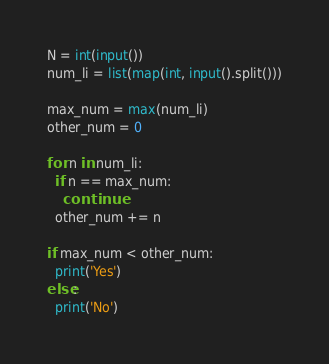Convert code to text. <code><loc_0><loc_0><loc_500><loc_500><_Python_>N = int(input())
num_li = list(map(int, input().split()))

max_num = max(num_li)
other_num = 0

for n in num_li:
  if n == max_num:
    continue
  other_num += n

if max_num < other_num:
  print('Yes')
else:
  print('No')
</code> 